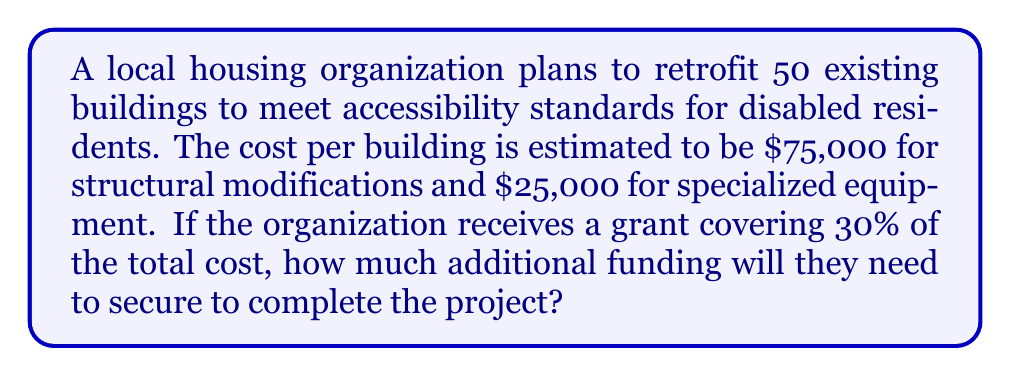Show me your answer to this math problem. Let's break this down step-by-step:

1) First, calculate the cost per building:
   Structural modifications: $75,000
   Specialized equipment: $25,000
   Total per building: $75,000 + $25,000 = $100,000

2) Calculate the total cost for all 50 buildings:
   $$50 \times $100,000 = $5,000,000$$

3) Calculate the amount covered by the grant (30% of total):
   $$30\% \text{ of } $5,000,000 = 0.30 \times $5,000,000 = $1,500,000$$

4) Calculate the remaining amount needed:
   $$\text{Total cost} - \text{Grant amount} = $5,000,000 - $1,500,000 = $3,500,000$$

Therefore, the organization needs to secure an additional $3,500,000 to complete the project.
Answer: $3,500,000 